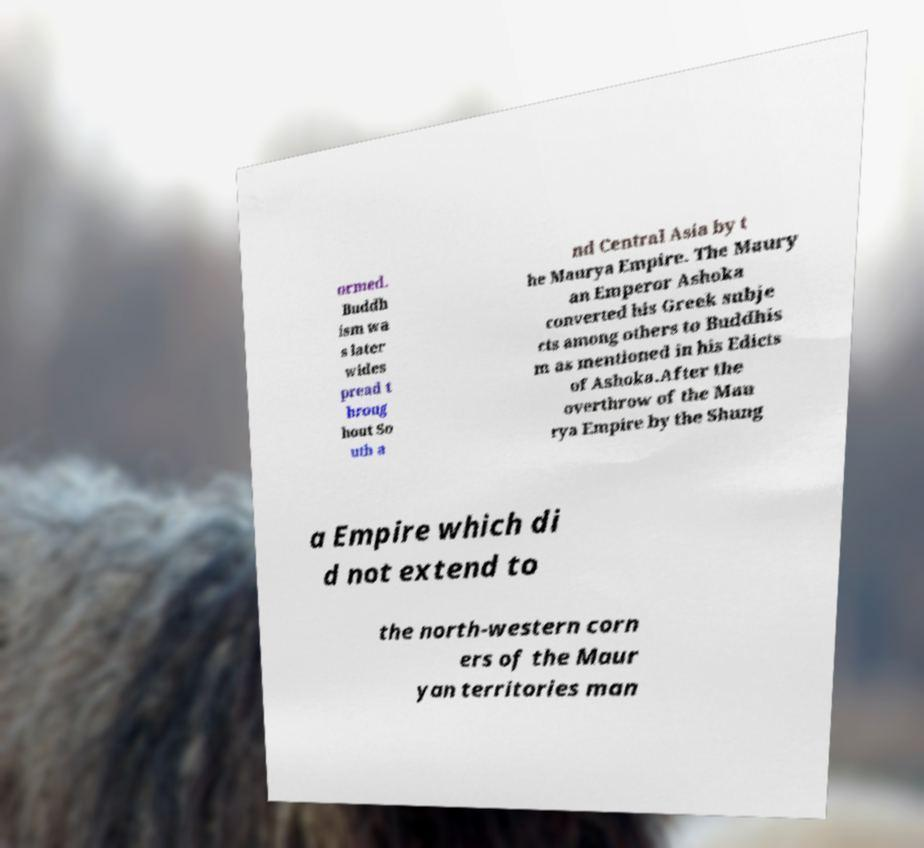Can you accurately transcribe the text from the provided image for me? ormed. Buddh ism wa s later wides pread t hroug hout So uth a nd Central Asia by t he Maurya Empire. The Maury an Emperor Ashoka converted his Greek subje cts among others to Buddhis m as mentioned in his Edicts of Ashoka.After the overthrow of the Mau rya Empire by the Shung a Empire which di d not extend to the north-western corn ers of the Maur yan territories man 